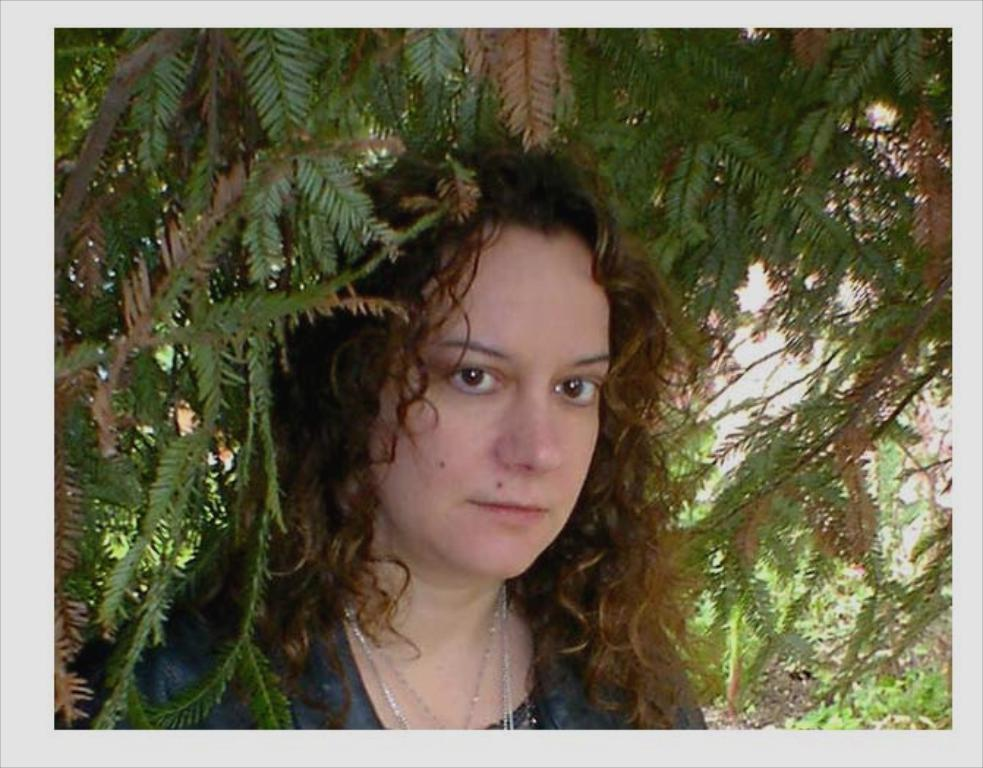What is the main subject of the image? There is a woman standing in the image. Can you describe the background of the image? There are leaves of a tree in the background of the image. What type of toy is the woman playing with in the image? There is no toy present in the image; the woman is simply standing. 